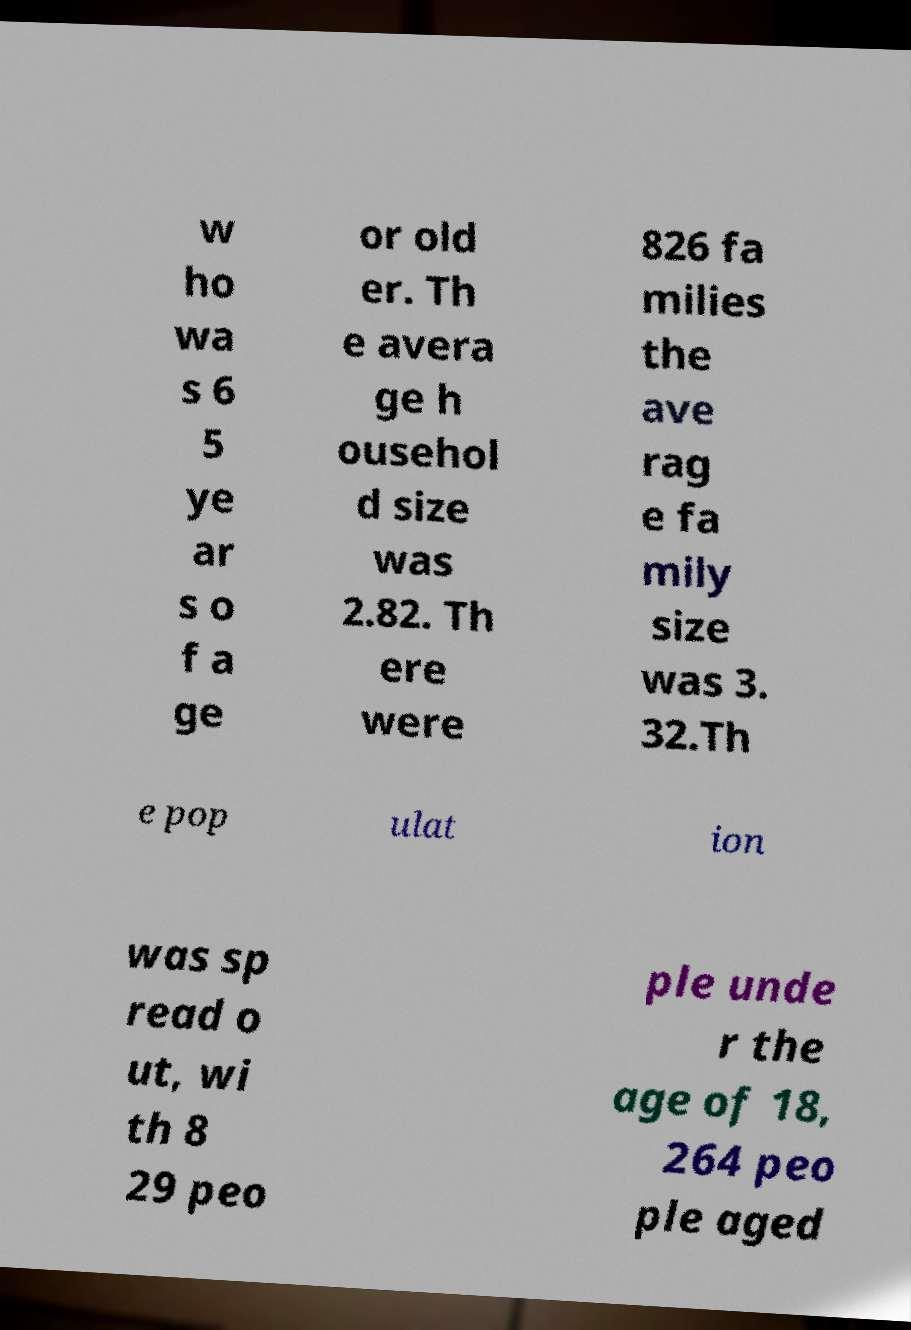Please read and relay the text visible in this image. What does it say? w ho wa s 6 5 ye ar s o f a ge or old er. Th e avera ge h ousehol d size was 2.82. Th ere were 826 fa milies the ave rag e fa mily size was 3. 32.Th e pop ulat ion was sp read o ut, wi th 8 29 peo ple unde r the age of 18, 264 peo ple aged 